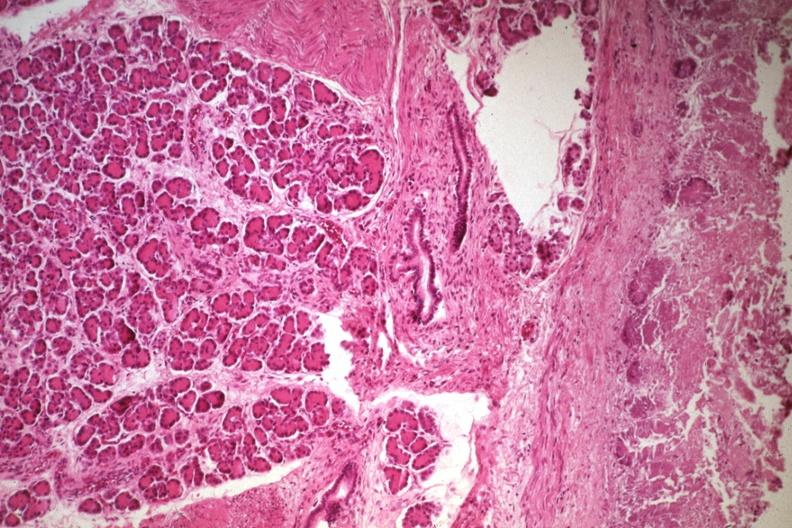what is present?
Answer the question using a single word or phrase. Jejunum 